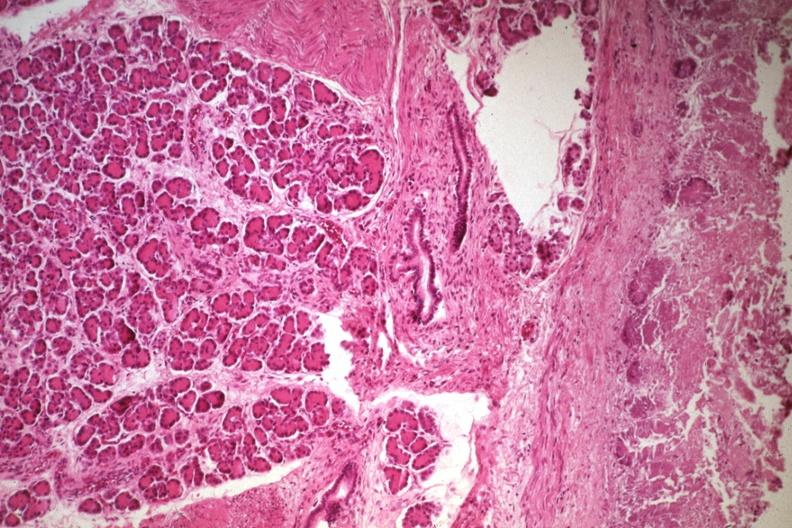what is present?
Answer the question using a single word or phrase. Jejunum 